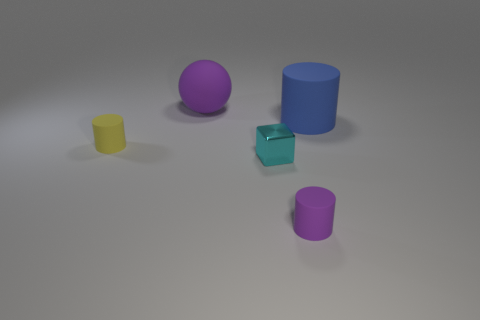Subtract all small rubber cylinders. How many cylinders are left? 1 Subtract all cylinders. How many objects are left? 2 Add 2 small yellow shiny objects. How many objects exist? 7 Subtract all yellow cylinders. How many cylinders are left? 2 Subtract 1 cylinders. How many cylinders are left? 2 Add 1 small cyan things. How many small cyan things are left? 2 Add 3 green rubber balls. How many green rubber balls exist? 3 Subtract 0 gray blocks. How many objects are left? 5 Subtract all red cubes. Subtract all purple cylinders. How many cubes are left? 1 Subtract all blue spheres. How many brown blocks are left? 0 